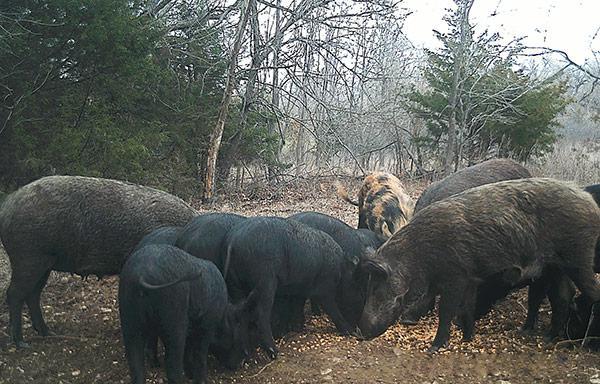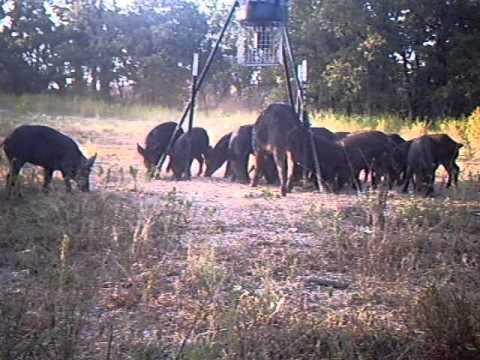The first image is the image on the left, the second image is the image on the right. For the images shown, is this caption "the right image contains no more than five boars." true? Answer yes or no. No. The first image is the image on the left, the second image is the image on the right. For the images displayed, is the sentence "In the image on the right all of the warthogs are walking to the left." factually correct? Answer yes or no. No. 